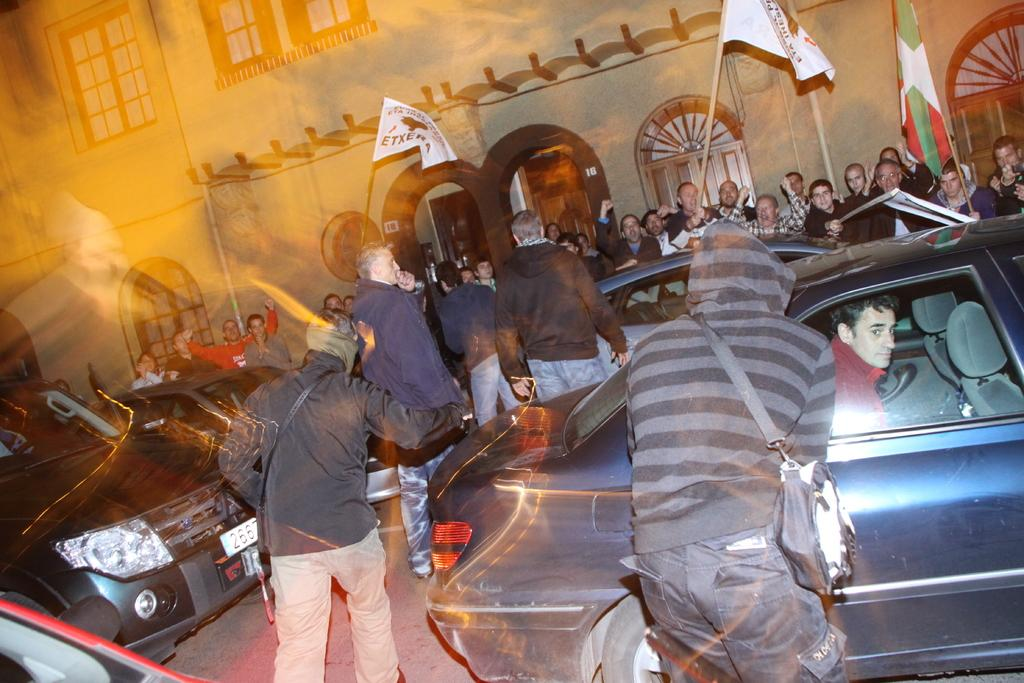What can be seen flying in the image? There are flags in the image. What type of structures are visible in the image? There are buildings in the image. What architectural feature can be seen on the buildings? There are windows in the image. Who or what can be seen in the image? There are people in the image. What mode of transportation is present in the image? There are cars in the image. Can you see the seashore in the image? There is no seashore present in the image. What type of stick is being used by the people in the image? There is no stick visible in the image. 